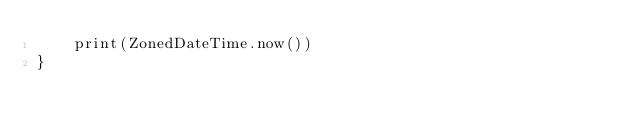<code> <loc_0><loc_0><loc_500><loc_500><_Kotlin_>    print(ZonedDateTime.now())
}</code> 